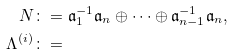Convert formula to latex. <formula><loc_0><loc_0><loc_500><loc_500>N & \colon = \mathfrak a _ { 1 } ^ { - 1 } \mathfrak a _ { n } \oplus \cdots \oplus \mathfrak a _ { n - 1 } ^ { - 1 } \mathfrak a _ { n } , \\ \Lambda ^ { ( i ) } & \colon =</formula> 